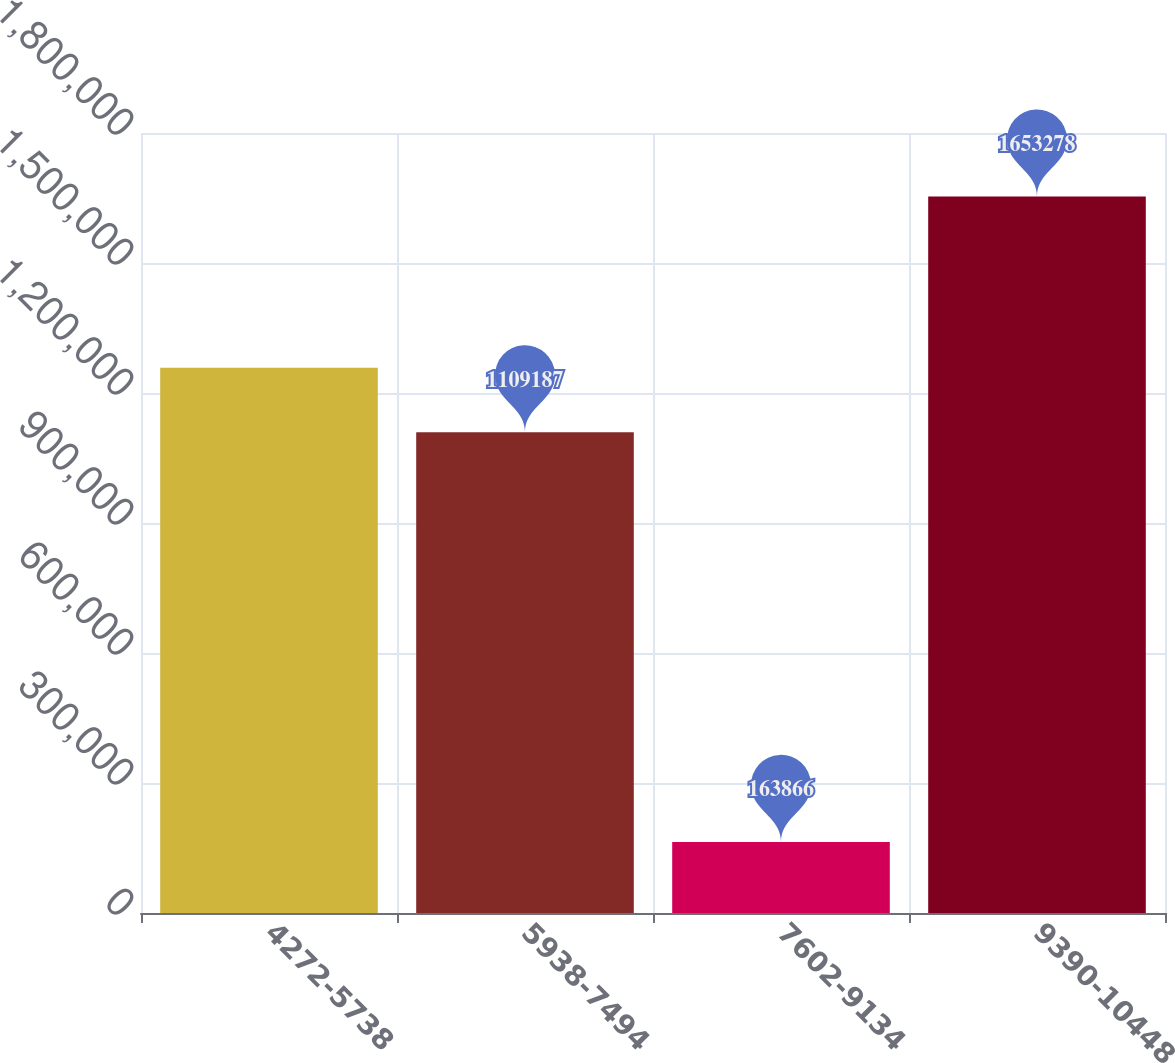<chart> <loc_0><loc_0><loc_500><loc_500><bar_chart><fcel>4272-5738<fcel>5938-7494<fcel>7602-9134<fcel>9390-10448<nl><fcel>1.25813e+06<fcel>1.10919e+06<fcel>163866<fcel>1.65328e+06<nl></chart> 